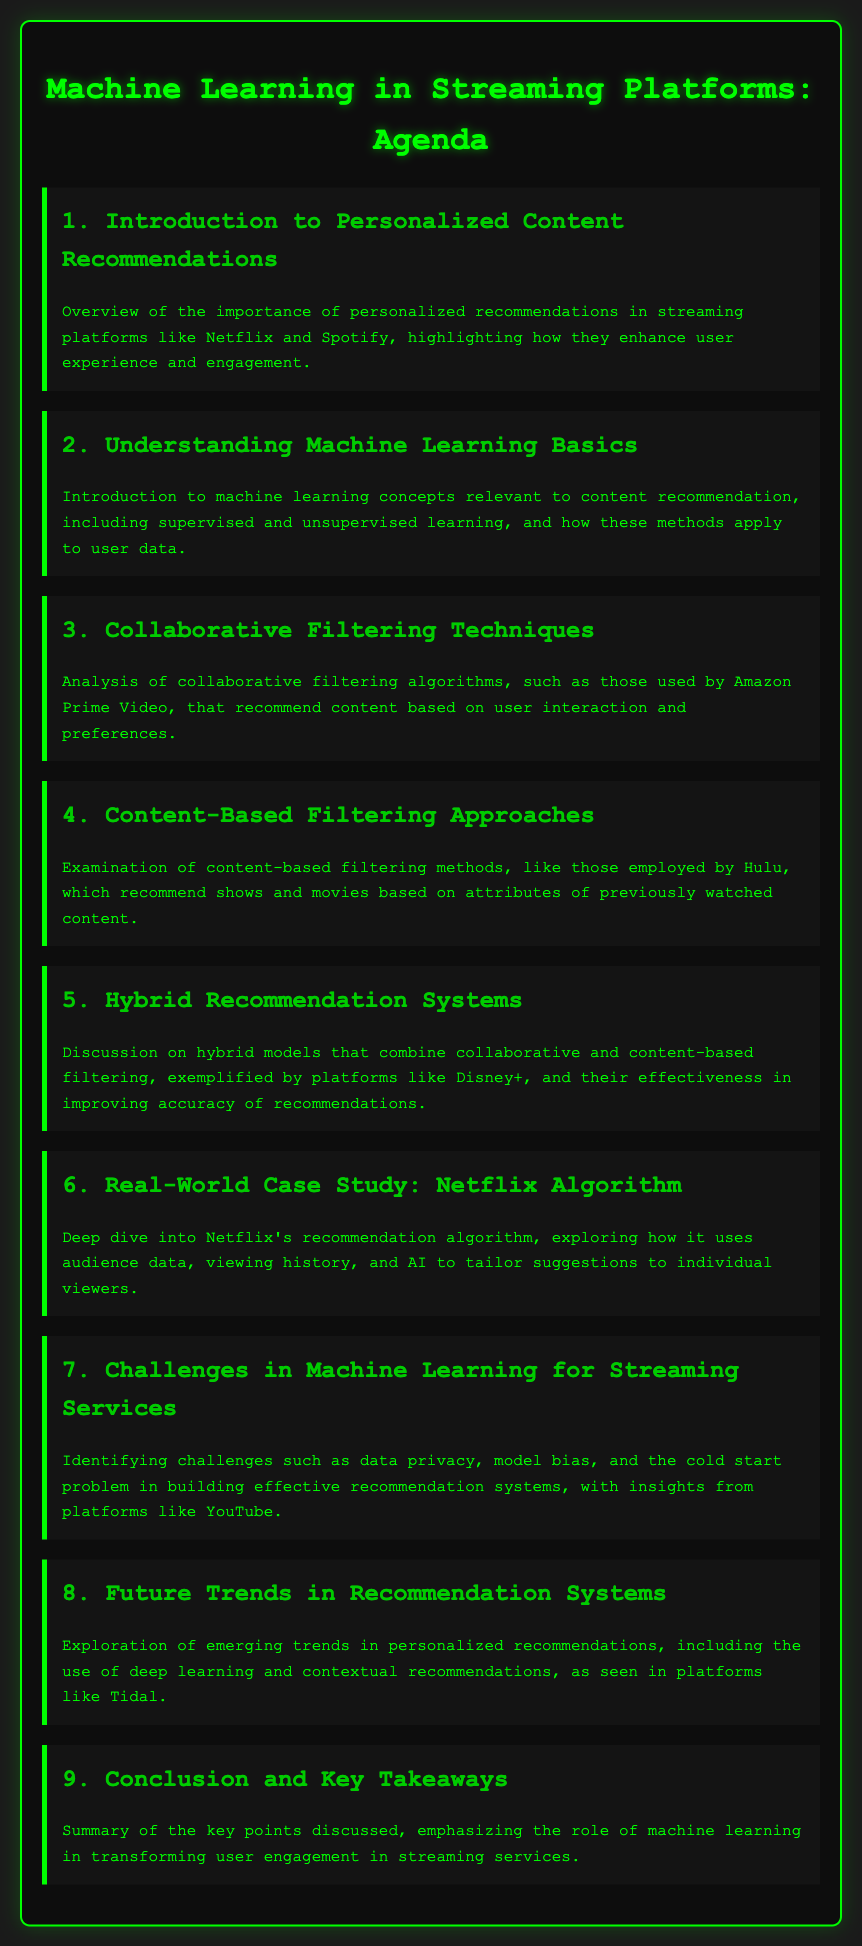What is the first agenda item? The first agenda item is an introduction, which sets the stage for the topics to be covered concerning personalized recommendations.
Answer: Introduction to Personalized Content Recommendations How many agenda items are listed? The document contains a total of nine agenda items, covering various aspects of personalized content recommendations.
Answer: 9 What term describes the algorithm discussed in agenda item six? The sixth agenda item presents a deep dive into a specific recommendation algorithm used by Netflix.
Answer: Netflix Algorithm Which platform is mentioned in connection with hybrid recommendation systems? The document specifies Disney+ as a platform that utilizes hybrid models in its recommendation systems.
Answer: Disney+ What challenge is highlighted in agenda item seven? The seventh agenda item discusses challenges faced by machine learning in streaming services, such as data privacy issues.
Answer: Data privacy What method is used in content-based filtering approaches? The document states that content-based filtering uses attributes of previously watched content for making recommendations.
Answer: Attributes of previously watched content What does the term "cold start problem" refer to? The cold start problem is identified as a challenge in building effective recommendation systems in the document.
Answer: Cold start problem Which platform is used as an example of collaborative filtering techniques? The document mentions Amazon Prime Video when analyzing collaborative filtering algorithms used for recommendations.
Answer: Amazon Prime Video What future trend in recommendation systems is discussed? The document indicates that deep learning is among the emerging trends being discussed regarding personalized recommendations.
Answer: Deep learning 